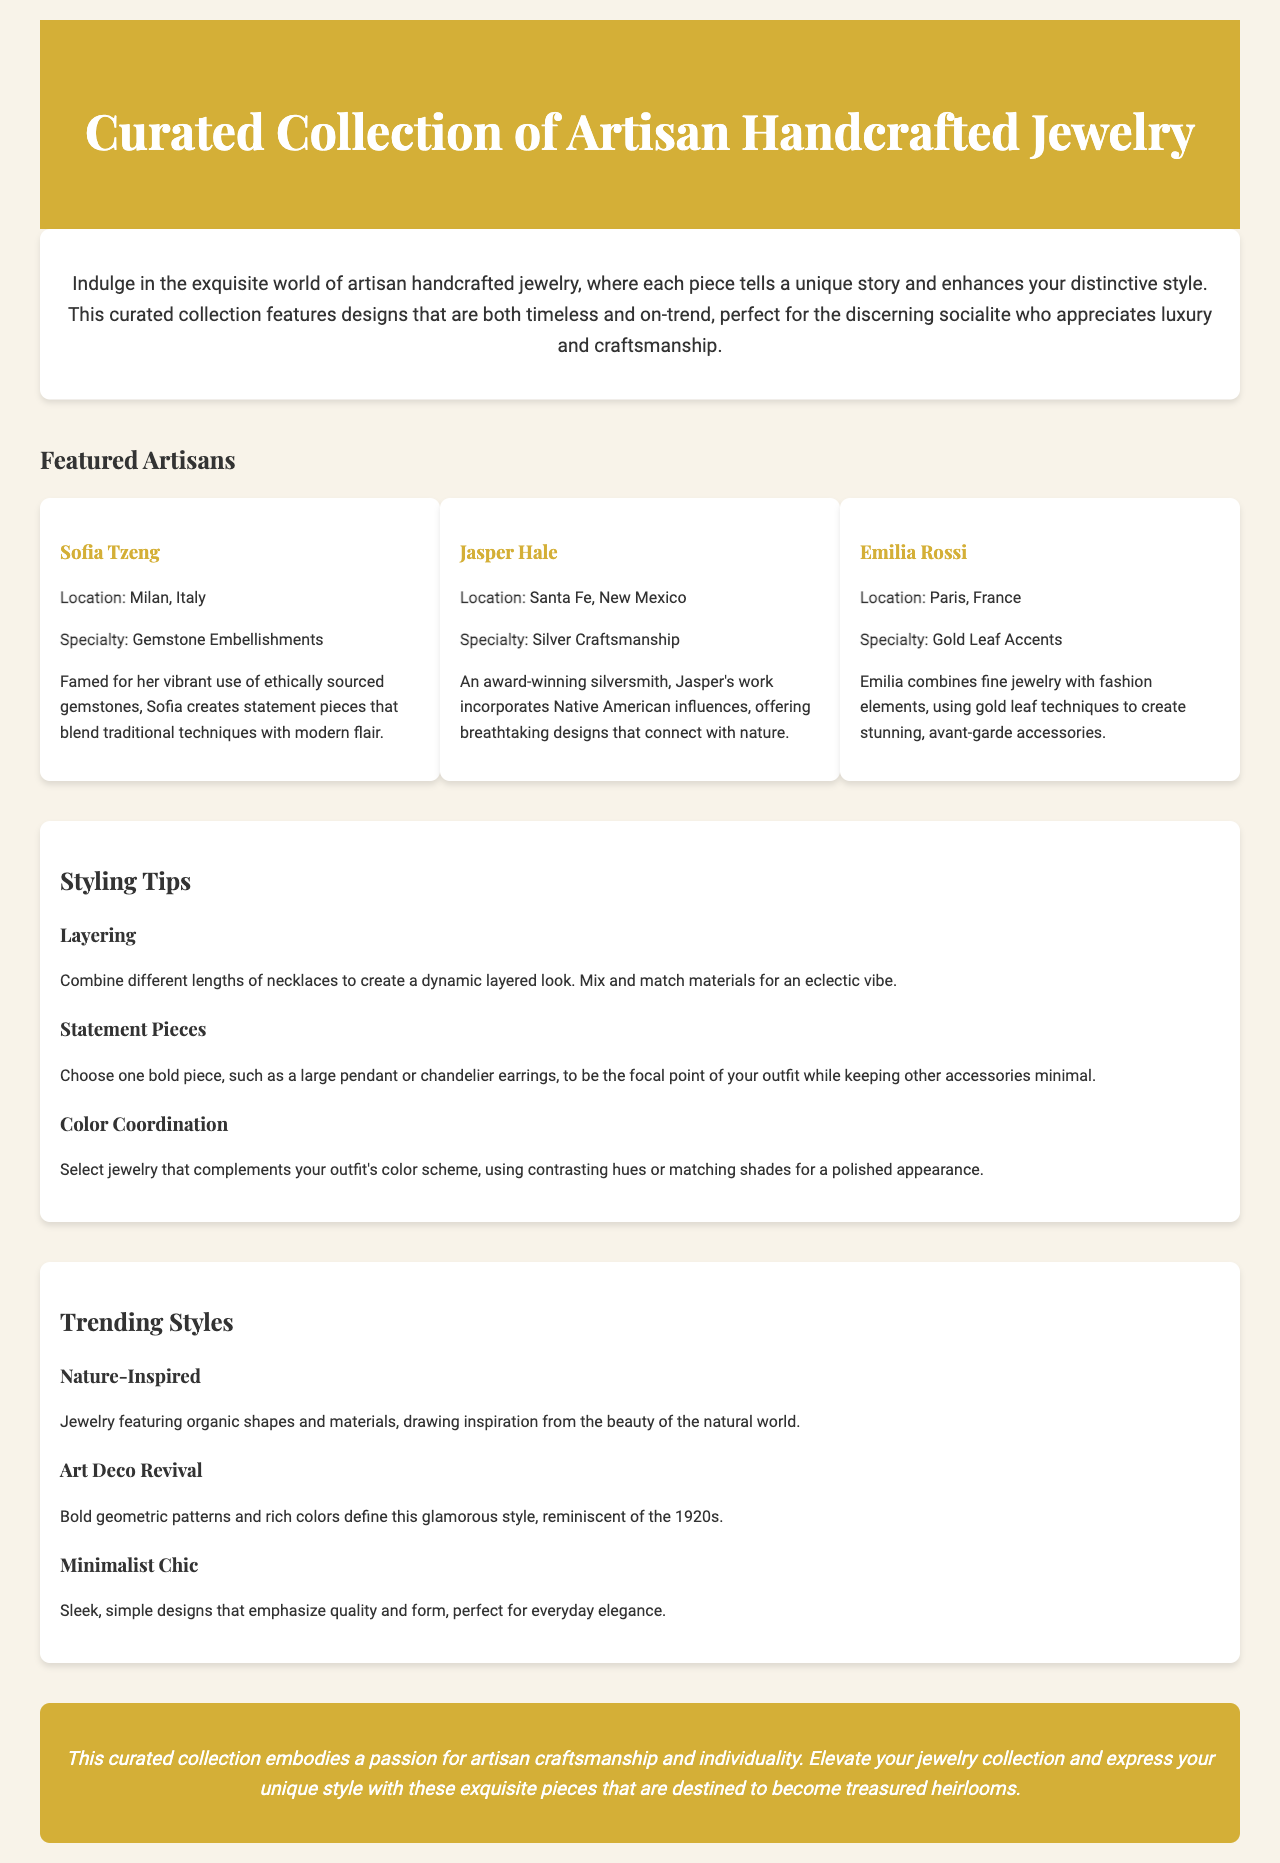what is the title of the brochure? The title of the brochure is stated in the header section of the document.
Answer: Curated Collection of Artisan Handcrafted Jewelry who is the artisan known for gemstone embellishments? The document mentions Sofia Tzeng as the artisan specializing in gemstone embellishments.
Answer: Sofia Tzeng which location is associated with Jasper Hale? The document provides Jasper Hale's location in his artisan section.
Answer: Santa Fe, New Mexico how many styling tips are provided in the document? The document lists a specific number of styling tips under the styling tips section.
Answer: Three what style features bold geometric patterns and rich colors? The document describes a specific trending style with these characteristics.
Answer: Art Deco Revival who combines fine jewelry with fashion elements? The artisan specialty section identifies this artisan by name.
Answer: Emilia Rossi what is the main theme of the curated collection? The introductory paragraph summarizes the overarching theme of the collection.
Answer: Artisan craftsmanship and individuality name one element used in minimalist chic jewelry. The document provides a descriptor for minimalist chic style in the trending styles section.
Answer: Simple designs 